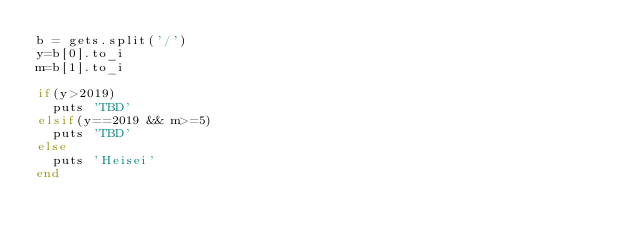Convert code to text. <code><loc_0><loc_0><loc_500><loc_500><_Ruby_>b = gets.split('/')
y=b[0].to_i
m=b[1].to_i

if(y>2019)
  puts 'TBD'
elsif(y==2019 && m>=5)
  puts 'TBD'
else
  puts 'Heisei'
end</code> 